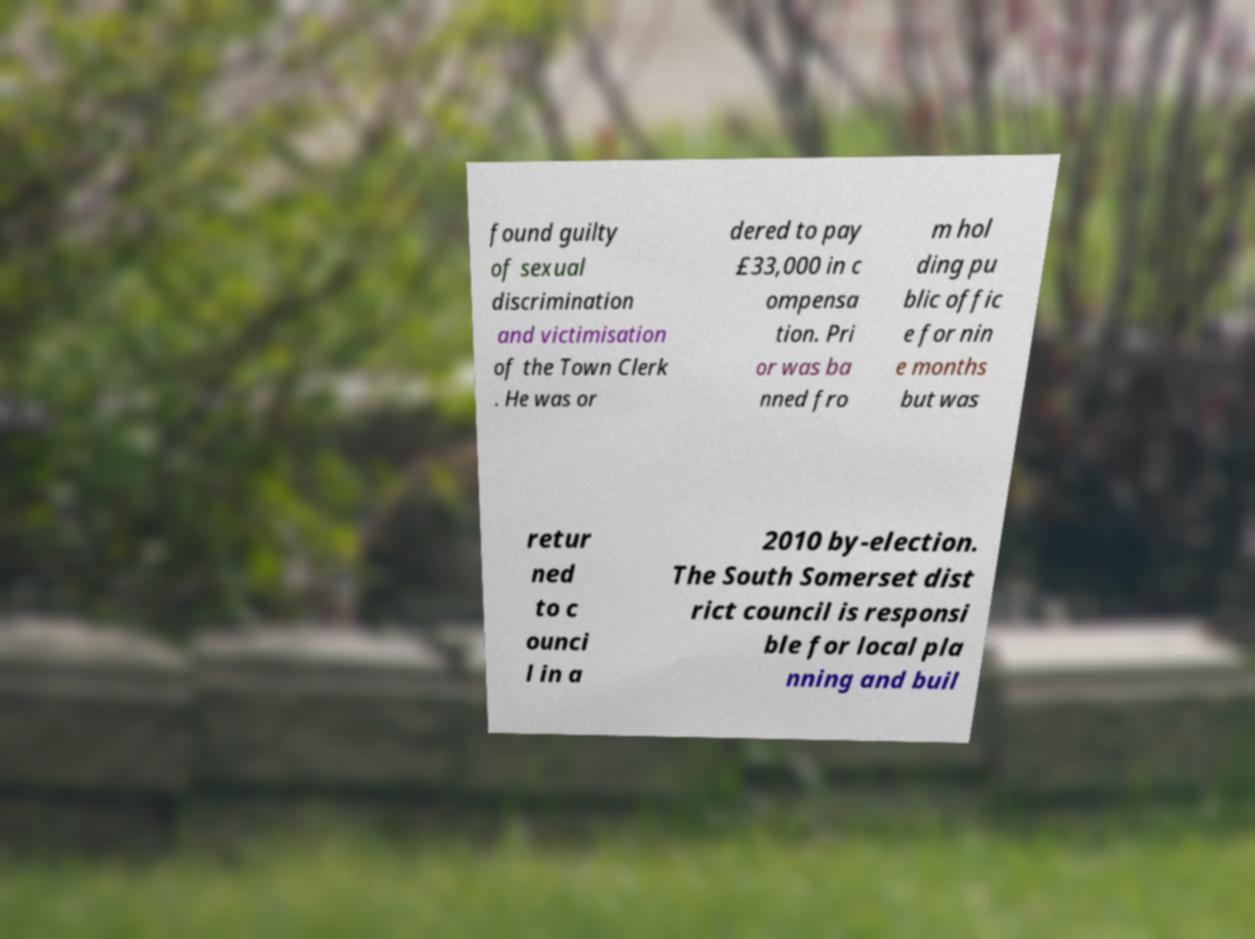Please read and relay the text visible in this image. What does it say? found guilty of sexual discrimination and victimisation of the Town Clerk . He was or dered to pay £33,000 in c ompensa tion. Pri or was ba nned fro m hol ding pu blic offic e for nin e months but was retur ned to c ounci l in a 2010 by-election. The South Somerset dist rict council is responsi ble for local pla nning and buil 